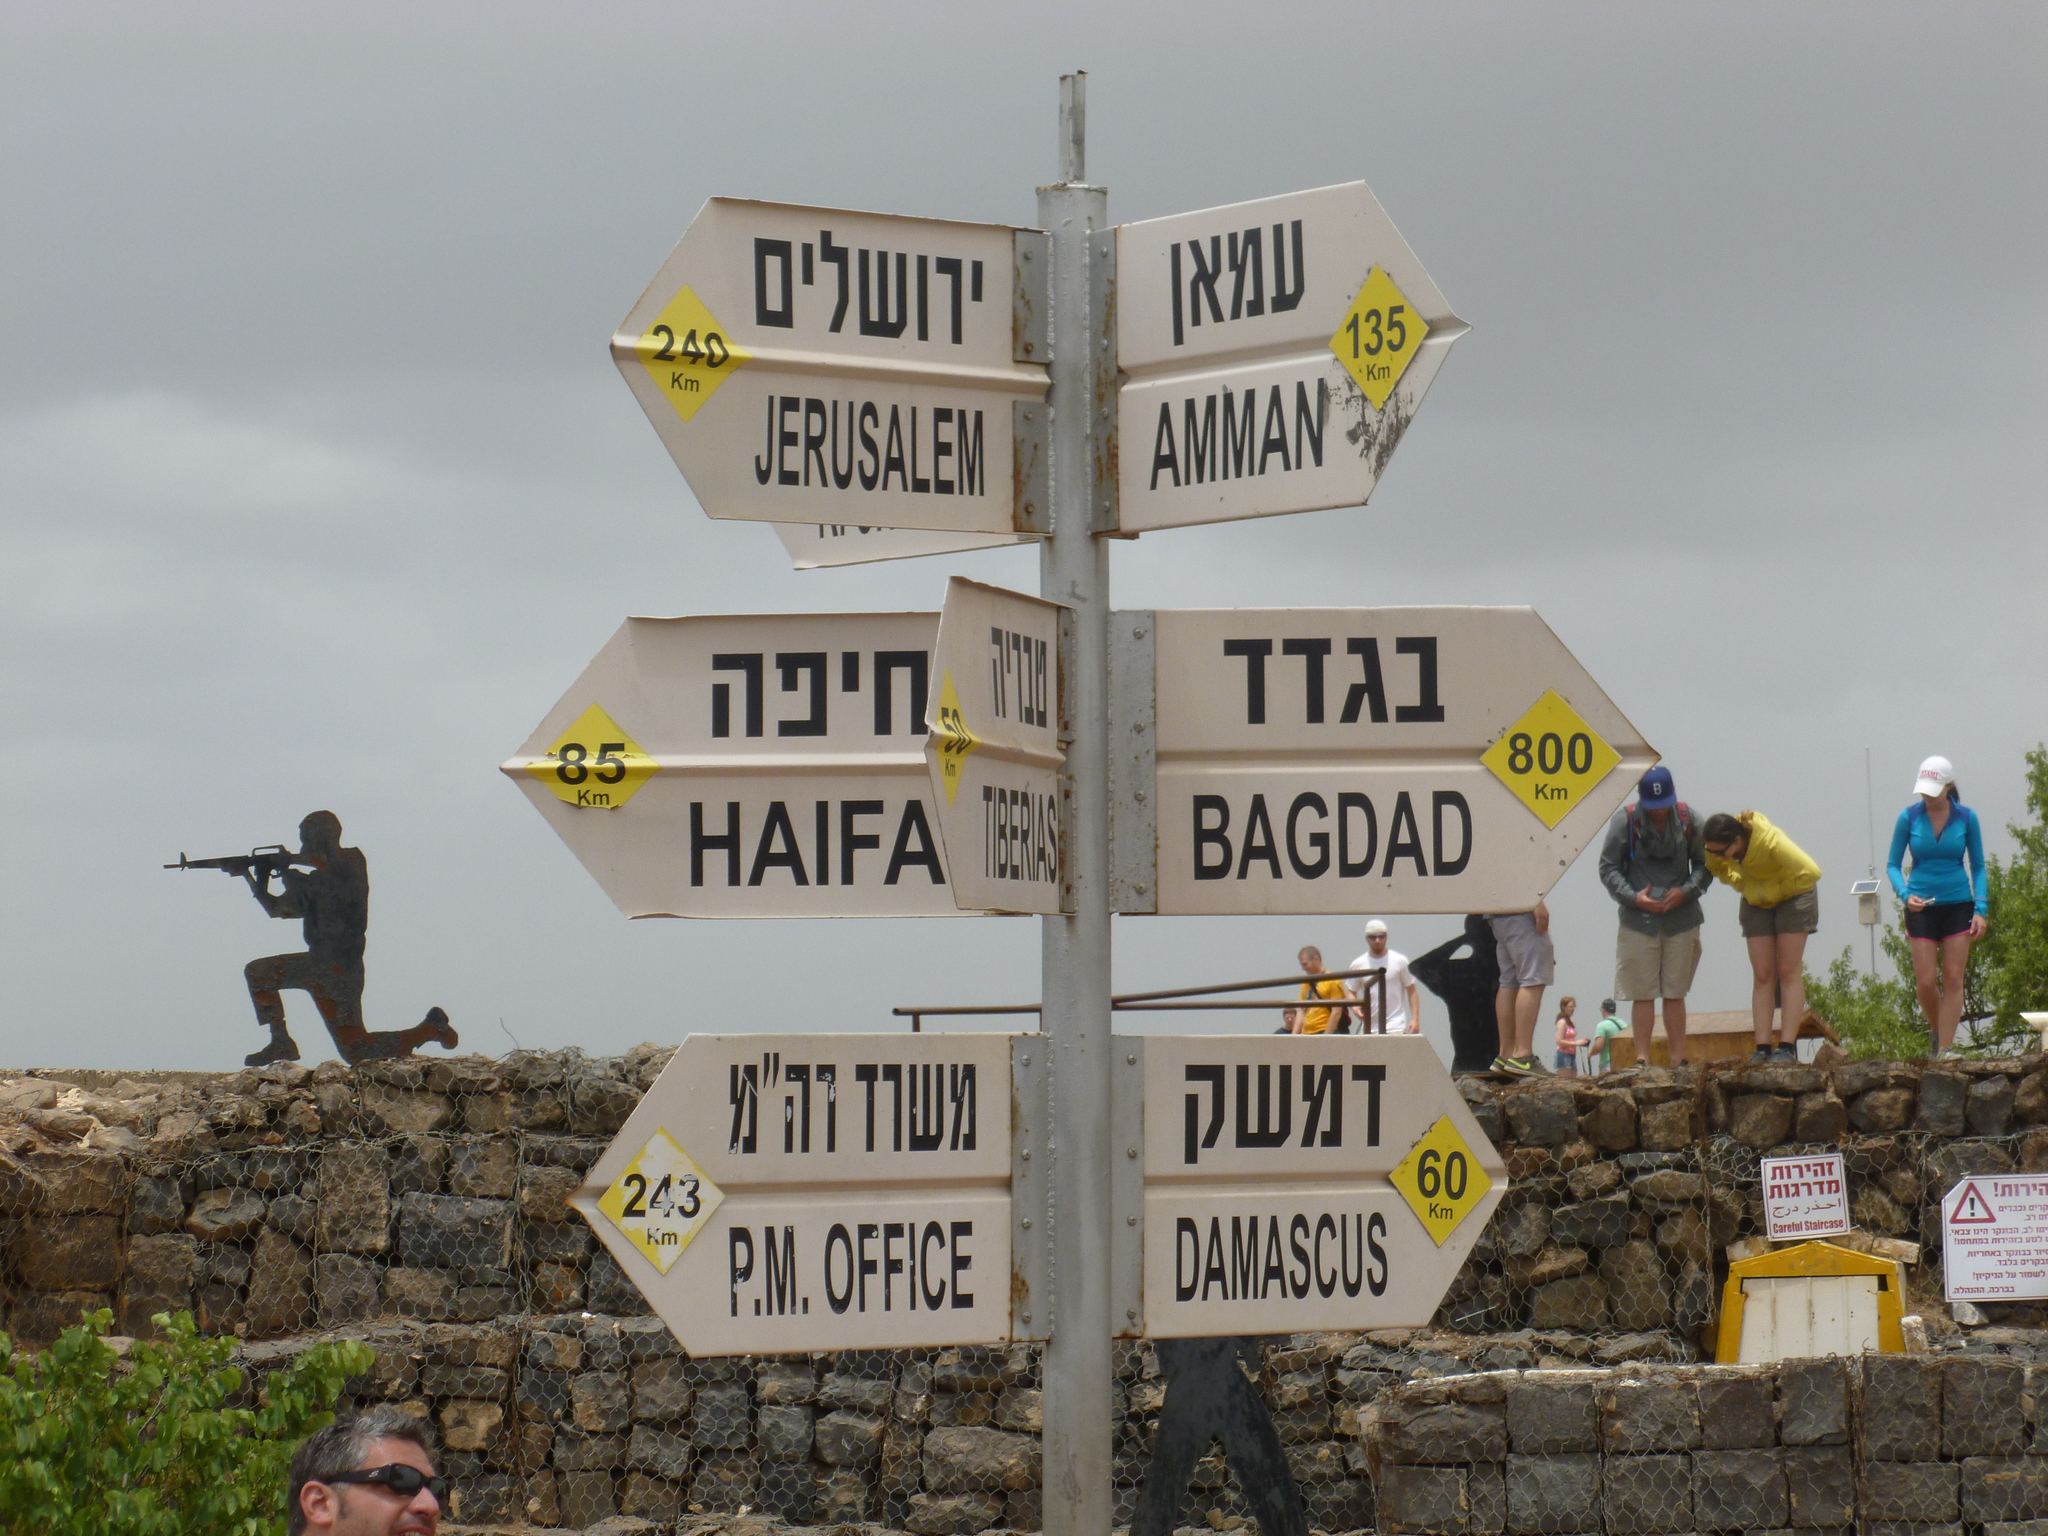<image>
Give a short and clear explanation of the subsequent image. Multiple signs on top of one another with the bottom one saying "Damascus". 